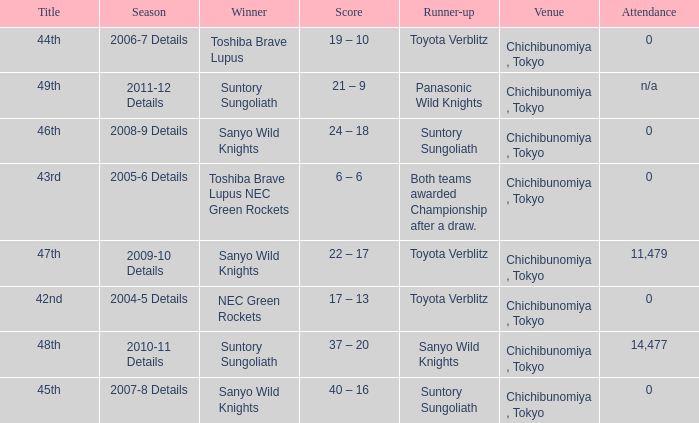Parse the full table. {'header': ['Title', 'Season', 'Winner', 'Score', 'Runner-up', 'Venue', 'Attendance'], 'rows': [['44th', '2006-7 Details', 'Toshiba Brave Lupus', '19 – 10', 'Toyota Verblitz', 'Chichibunomiya , Tokyo', '0'], ['49th', '2011-12 Details', 'Suntory Sungoliath', '21 – 9', 'Panasonic Wild Knights', 'Chichibunomiya , Tokyo', 'n/a'], ['46th', '2008-9 Details', 'Sanyo Wild Knights', '24 – 18', 'Suntory Sungoliath', 'Chichibunomiya , Tokyo', '0'], ['43rd', '2005-6 Details', 'Toshiba Brave Lupus NEC Green Rockets', '6 – 6', 'Both teams awarded Championship after a draw.', 'Chichibunomiya , Tokyo', '0'], ['47th', '2009-10 Details', 'Sanyo Wild Knights', '22 – 17', 'Toyota Verblitz', 'Chichibunomiya , Tokyo', '11,479'], ['42nd', '2004-5 Details', 'NEC Green Rockets', '17 – 13', 'Toyota Verblitz', 'Chichibunomiya , Tokyo', '0'], ['48th', '2010-11 Details', 'Suntory Sungoliath', '37 – 20', 'Sanyo Wild Knights', 'Chichibunomiya , Tokyo', '14,477'], ['45th', '2007-8 Details', 'Sanyo Wild Knights', '40 – 16', 'Suntory Sungoliath', 'Chichibunomiya , Tokyo', '0']]} What is the Title when the winner was suntory sungoliath, and a Season of 2011-12 details? 49th. 